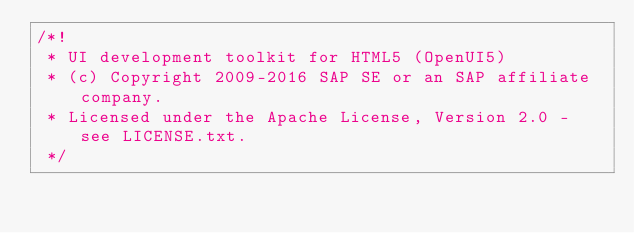<code> <loc_0><loc_0><loc_500><loc_500><_JavaScript_>/*!
 * UI development toolkit for HTML5 (OpenUI5)
 * (c) Copyright 2009-2016 SAP SE or an SAP affiliate company.
 * Licensed under the Apache License, Version 2.0 - see LICENSE.txt.
 */</code> 